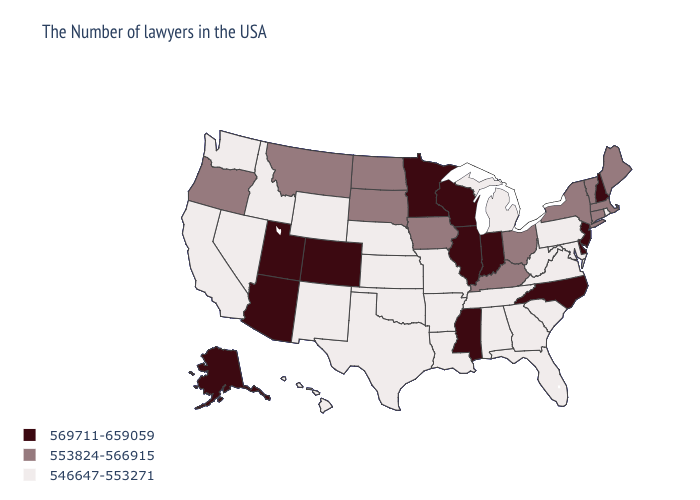Which states have the lowest value in the Northeast?
Write a very short answer. Rhode Island, Pennsylvania. Does Delaware have the same value as Iowa?
Short answer required. No. Name the states that have a value in the range 569711-659059?
Write a very short answer. New Hampshire, New Jersey, Delaware, North Carolina, Indiana, Wisconsin, Illinois, Mississippi, Minnesota, Colorado, Utah, Arizona, Alaska. What is the value of Indiana?
Concise answer only. 569711-659059. What is the value of Florida?
Write a very short answer. 546647-553271. Which states have the lowest value in the USA?
Write a very short answer. Rhode Island, Maryland, Pennsylvania, Virginia, South Carolina, West Virginia, Florida, Georgia, Michigan, Alabama, Tennessee, Louisiana, Missouri, Arkansas, Kansas, Nebraska, Oklahoma, Texas, Wyoming, New Mexico, Idaho, Nevada, California, Washington, Hawaii. Does Florida have the lowest value in the South?
Concise answer only. Yes. How many symbols are there in the legend?
Short answer required. 3. What is the value of Tennessee?
Write a very short answer. 546647-553271. Name the states that have a value in the range 553824-566915?
Answer briefly. Maine, Massachusetts, Vermont, Connecticut, New York, Ohio, Kentucky, Iowa, South Dakota, North Dakota, Montana, Oregon. Does the map have missing data?
Keep it brief. No. Name the states that have a value in the range 553824-566915?
Write a very short answer. Maine, Massachusetts, Vermont, Connecticut, New York, Ohio, Kentucky, Iowa, South Dakota, North Dakota, Montana, Oregon. What is the value of Maryland?
Keep it brief. 546647-553271. Name the states that have a value in the range 546647-553271?
Write a very short answer. Rhode Island, Maryland, Pennsylvania, Virginia, South Carolina, West Virginia, Florida, Georgia, Michigan, Alabama, Tennessee, Louisiana, Missouri, Arkansas, Kansas, Nebraska, Oklahoma, Texas, Wyoming, New Mexico, Idaho, Nevada, California, Washington, Hawaii. 